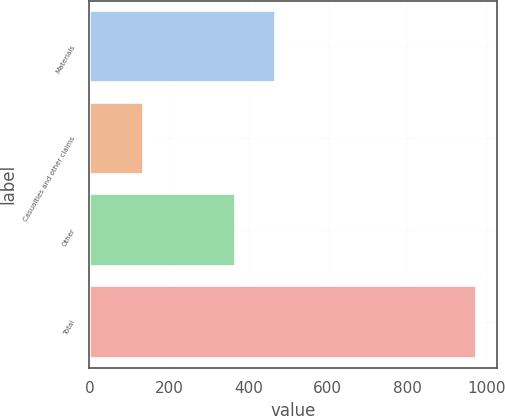<chart> <loc_0><loc_0><loc_500><loc_500><bar_chart><fcel>Materials<fcel>Casualties and other claims<fcel>Other<fcel>Total<nl><fcel>469<fcel>137<fcel>370<fcel>976<nl></chart> 